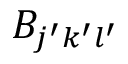<formula> <loc_0><loc_0><loc_500><loc_500>B _ { j ^ { \prime } k ^ { \prime } l ^ { \prime } }</formula> 